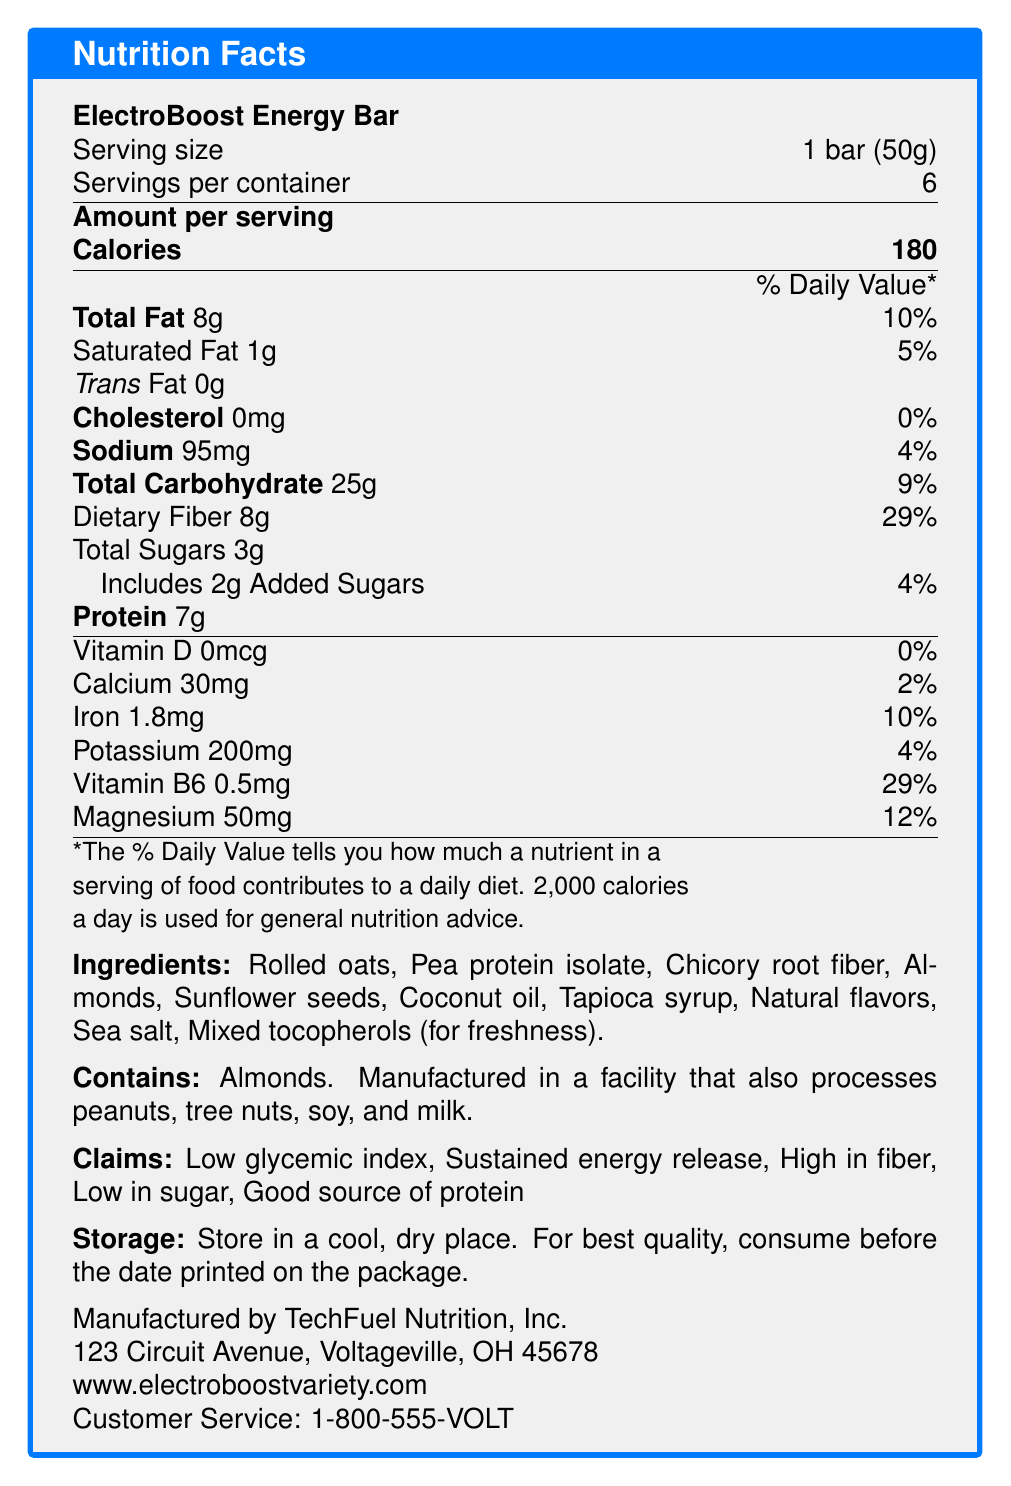what is the serving size for ElectroBoost Energy Bar? The serving size is specified in the first few lines of the document: "Serving size: 1 bar (50g)."
Answer: 1 bar (50g) How many calories are in one serving of the ElectroBoost Energy Bar? The document states "Calories: 180" under the section "Amount per serving."
Answer: 180 What percentage of the Daily Value of dietary fiber does one serving of this bar provide? The document lists "Dietary Fiber: 8g (29% DV)" in the nutrition details.
Answer: 29% What are the total carbohydrates per serving? The document indicates "Total Carbohydrate: 25g" in the nutritional information.
Answer: 25g What is the allergen information for this product? This is specified under the allergen information section: "Contains: Almonds. Manufactured in a facility that also processes peanuts, tree nuts, soy, and milk."
Answer: Contains almonds. Manufactured in a facility that also processes peanuts, tree nuts, soy, and milk. How much protein does one ElectroBoost Energy Bar provide? The document states "Protein: 7g" in the nutritional facts section.
Answer: 7g Which vitamin/mineral listed has the highest percent daily value per serving? A. Vitamin D B. Calcium C. Iron D. Vitamin B6 The document indicates that Vitamin B6 has the highest percent daily value at 29%.
Answer: D How many servings are there per container? The document mentions "Servings per container: 6" in the initial details.
Answer: 6 Does the product have any trans fat? The document specifies that the Trans Fat content is 0g.
Answer: No (0g) Which ingredient is not present in the ElectroBoost Energy Bar? A. Almonds B. Soy protein isolate C. Coconut oil D. Rolled oats The listed ingredients include almonds, coconut oil, and rolled oats, but not soy protein isolate.
Answer: B Is the ElectroBoost Energy Bar a good source of Vitamin D? The document shows "Vitamin D: 0mcg (0% DV)" indicating there is no Vitamin D.
Answer: No Summarize the main features and claims of the ElectroBoost Energy Bar The document provides detailed nutrition facts, ingredients, allergen information, claims, storage instructions, and manufacturer details. It highlights the bar's nutritional advantages and supports its claims with specific nutrient data.
Answer: The ElectroBoost Energy Bar is designed to provide steady energy with key features like high fiber, low sugar, and a good source of protein. It contains 180 calories per serving, with 8g of fat, 25g of carbs, 8g of dietary fiber, and 7g of protein. The bar includes ingredients like rolled oats and pea protein isolate, and it's manufactured in a facility handling multiple allergens. It is marketed for its low glycemic index and sustained energy release. What is the customer service phone number for TechFuel Nutrition, Inc.? This is listed at the end of the document under customer service information.
Answer: 1-800-555-VOLT What type of fiber is included in the ElectroBoost Energy Bar? The ingredient list includes "Chicory root fiber."
Answer: Chicory root fiber What is the address of the manufacturer of the ElectroBoost Energy Bar? This information is provided in the manufacturer section.
Answer: 123 Circuit Avenue, Voltageville, OH 45678 Does the ElectroBoost Energy Bar include any added sugars? If yes, how much? The nutrition facts state "Includes 2g Added Sugars (4% DV)."
Answer: Yes, 2g What are the natural flavors used in the ElectroBoost Energy Bar? The document mentions "Natural flavors," but does not specify what these flavors are.
Answer: Not enough information 